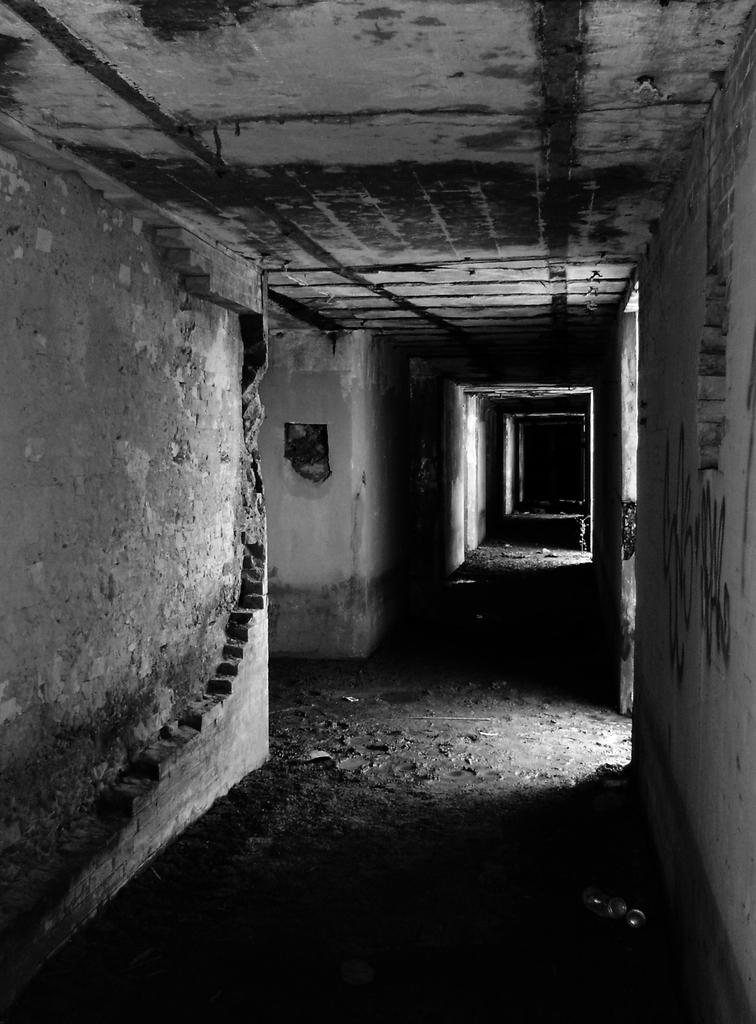What is the color scheme of the image? The image is black and white. What can be seen in the image? There is a corridor in the image. How do the walls in the corridor appear? The walls in the corridor have been partially destroyed. Can you see a note left on the seat in the image? There is no seat present in the image, and therefore no note can be seen. 